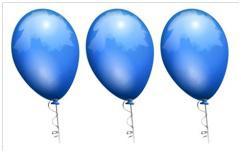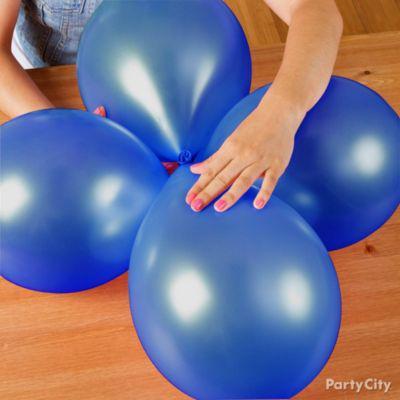The first image is the image on the left, the second image is the image on the right. For the images shown, is this caption "AN image shows at least three blue balloons displayed with knot ends joined at the center." true? Answer yes or no. Yes. The first image is the image on the left, the second image is the image on the right. Considering the images on both sides, is "There are no more than three balloons in each image." valid? Answer yes or no. No. 